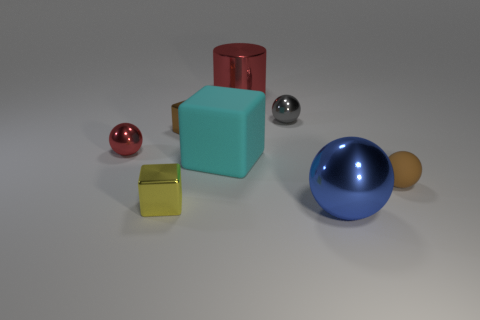Are there any other things that have the same color as the large cylinder?
Make the answer very short. Yes. There is a big cylinder; is its color the same as the small sphere on the left side of the tiny yellow cube?
Provide a succinct answer. Yes. Is the number of red objects behind the gray thing less than the number of green metallic cubes?
Make the answer very short. No. There is a object behind the tiny gray sphere; what material is it?
Ensure brevity in your answer.  Metal. How many other objects are there of the same size as the gray object?
Keep it short and to the point. 4. Does the gray ball have the same size as the matte ball in front of the big matte thing?
Your answer should be very brief. Yes. What is the shape of the red metallic thing to the right of the small metal sphere to the left of the block on the left side of the brown metal object?
Your response must be concise. Cylinder. Is the number of large blue shiny balls less than the number of tiny blue things?
Provide a short and direct response. No. There is a small gray sphere; are there any large shiny balls left of it?
Keep it short and to the point. No. The large object that is both in front of the brown block and behind the large metal sphere has what shape?
Give a very brief answer. Cube. 